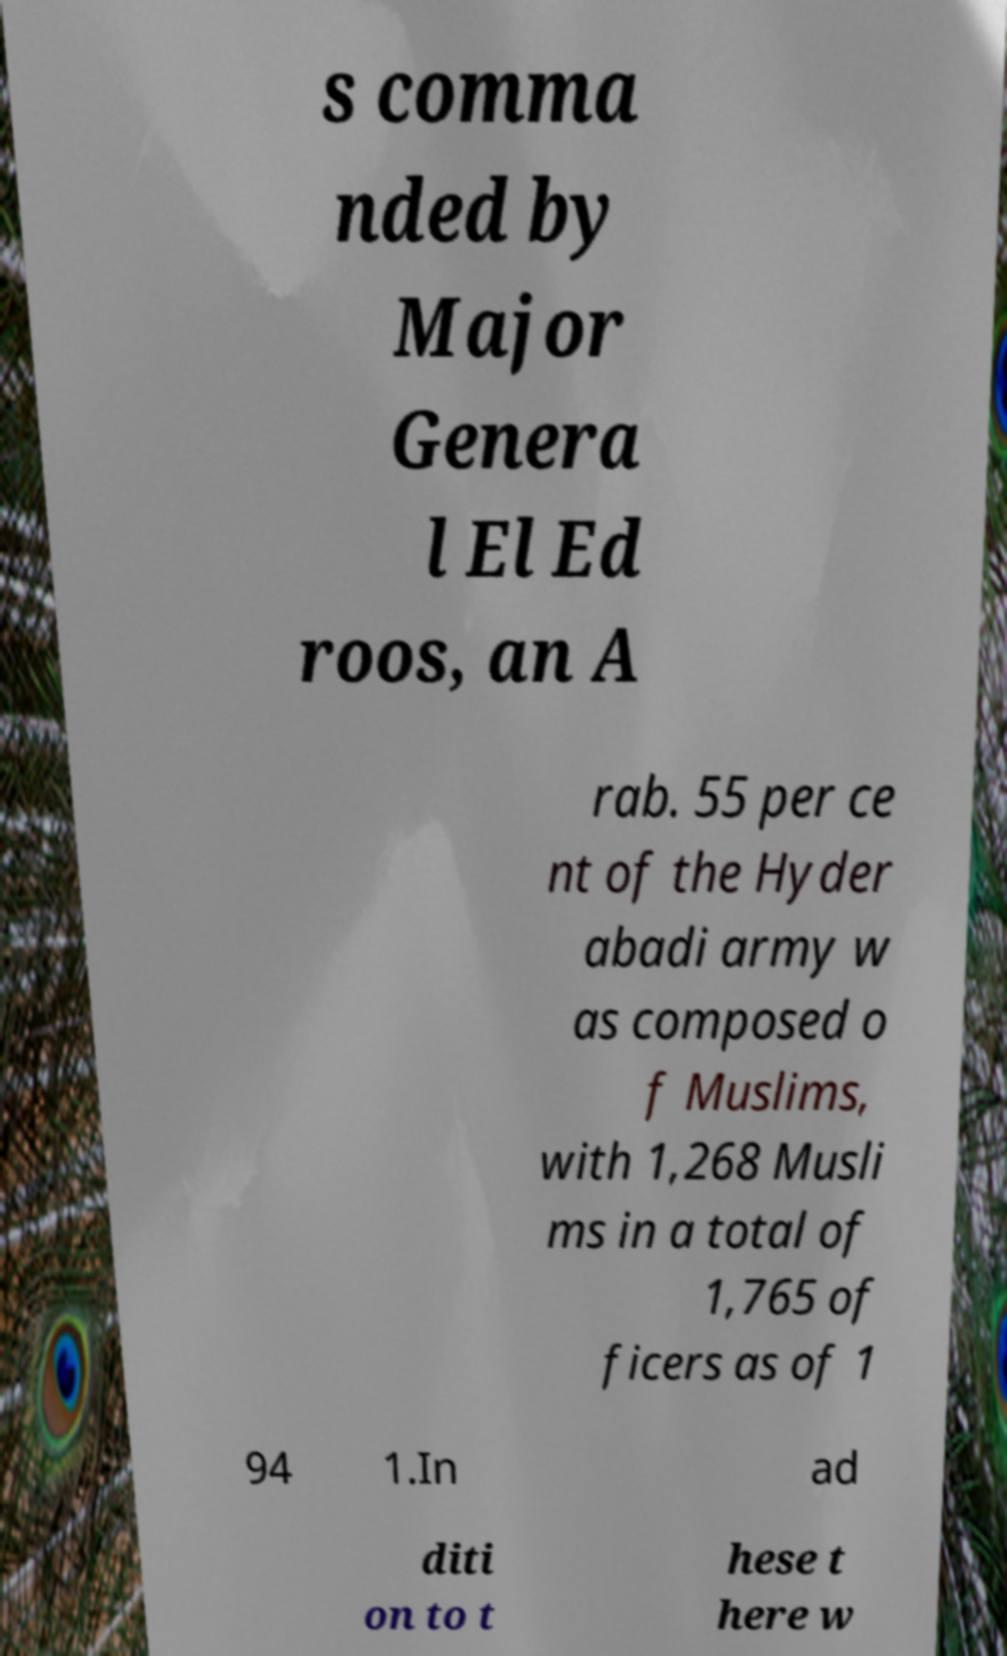Please identify and transcribe the text found in this image. s comma nded by Major Genera l El Ed roos, an A rab. 55 per ce nt of the Hyder abadi army w as composed o f Muslims, with 1,268 Musli ms in a total of 1,765 of ficers as of 1 94 1.In ad diti on to t hese t here w 